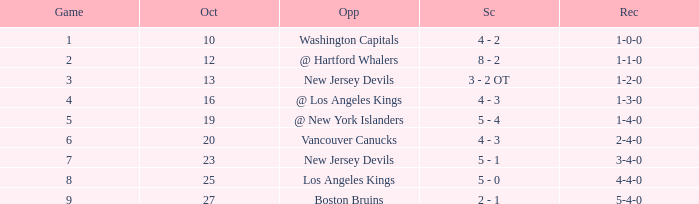What was the average game with a record of 4-4-0? 8.0. 